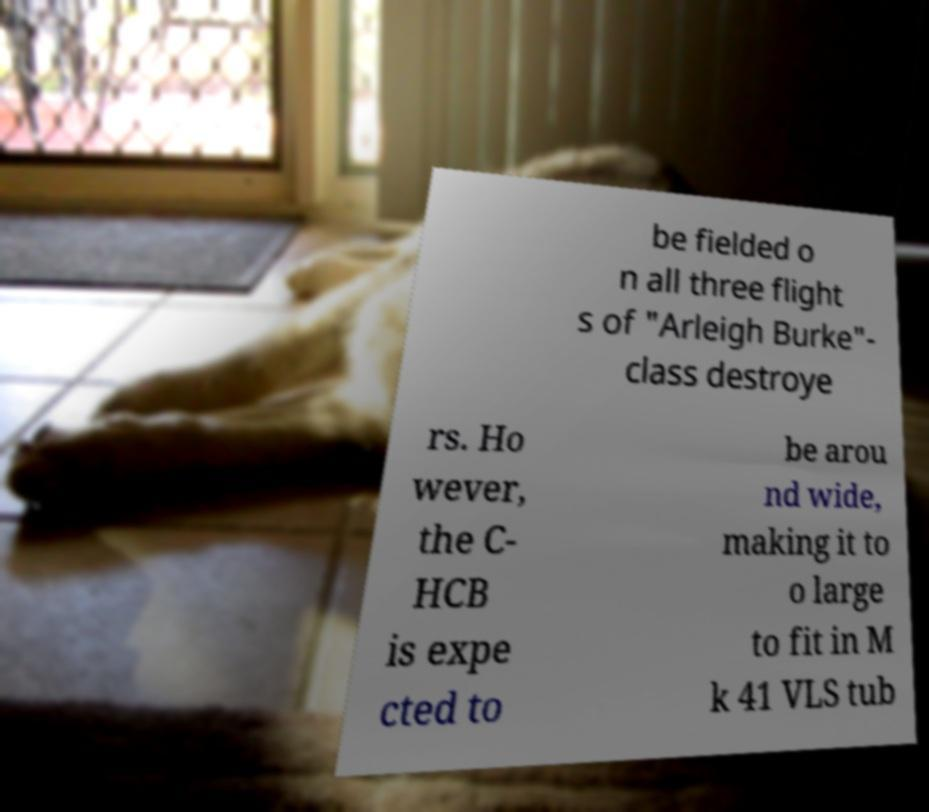For documentation purposes, I need the text within this image transcribed. Could you provide that? be fielded o n all three flight s of "Arleigh Burke"- class destroye rs. Ho wever, the C- HCB is expe cted to be arou nd wide, making it to o large to fit in M k 41 VLS tub 